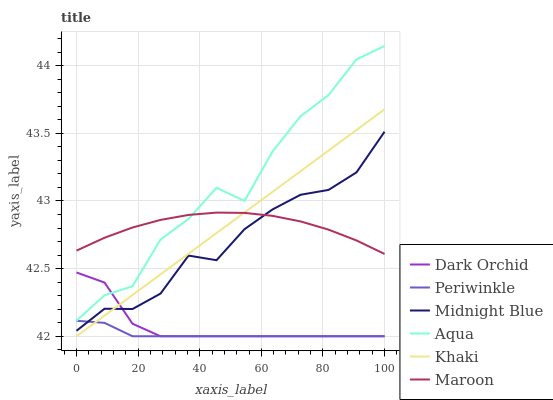Does Periwinkle have the minimum area under the curve?
Answer yes or no. Yes. Does Aqua have the maximum area under the curve?
Answer yes or no. Yes. Does Midnight Blue have the minimum area under the curve?
Answer yes or no. No. Does Midnight Blue have the maximum area under the curve?
Answer yes or no. No. Is Khaki the smoothest?
Answer yes or no. Yes. Is Aqua the roughest?
Answer yes or no. Yes. Is Midnight Blue the smoothest?
Answer yes or no. No. Is Midnight Blue the roughest?
Answer yes or no. No. Does Khaki have the lowest value?
Answer yes or no. Yes. Does Midnight Blue have the lowest value?
Answer yes or no. No. Does Aqua have the highest value?
Answer yes or no. Yes. Does Midnight Blue have the highest value?
Answer yes or no. No. Is Periwinkle less than Aqua?
Answer yes or no. Yes. Is Aqua greater than Midnight Blue?
Answer yes or no. Yes. Does Aqua intersect Dark Orchid?
Answer yes or no. Yes. Is Aqua less than Dark Orchid?
Answer yes or no. No. Is Aqua greater than Dark Orchid?
Answer yes or no. No. Does Periwinkle intersect Aqua?
Answer yes or no. No. 